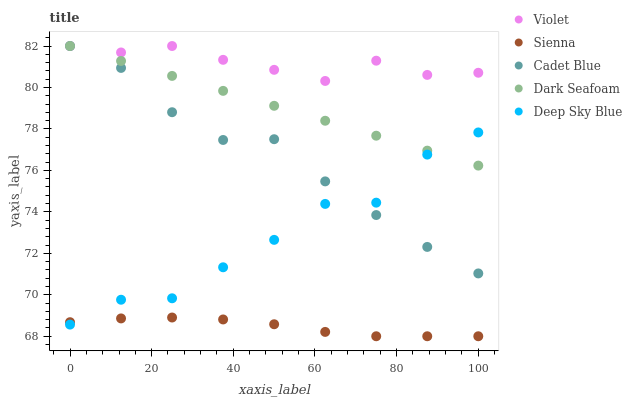Does Sienna have the minimum area under the curve?
Answer yes or no. Yes. Does Violet have the maximum area under the curve?
Answer yes or no. Yes. Does Dark Seafoam have the minimum area under the curve?
Answer yes or no. No. Does Dark Seafoam have the maximum area under the curve?
Answer yes or no. No. Is Dark Seafoam the smoothest?
Answer yes or no. Yes. Is Deep Sky Blue the roughest?
Answer yes or no. Yes. Is Cadet Blue the smoothest?
Answer yes or no. No. Is Cadet Blue the roughest?
Answer yes or no. No. Does Sienna have the lowest value?
Answer yes or no. Yes. Does Dark Seafoam have the lowest value?
Answer yes or no. No. Does Violet have the highest value?
Answer yes or no. Yes. Does Deep Sky Blue have the highest value?
Answer yes or no. No. Is Sienna less than Cadet Blue?
Answer yes or no. Yes. Is Violet greater than Sienna?
Answer yes or no. Yes. Does Violet intersect Dark Seafoam?
Answer yes or no. Yes. Is Violet less than Dark Seafoam?
Answer yes or no. No. Is Violet greater than Dark Seafoam?
Answer yes or no. No. Does Sienna intersect Cadet Blue?
Answer yes or no. No. 